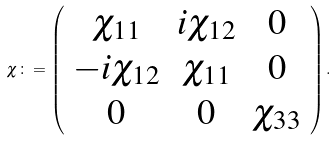<formula> <loc_0><loc_0><loc_500><loc_500>\chi \colon = \left ( \begin{array} { c c c } \chi _ { 1 1 } & i \chi _ { 1 2 } & 0 \\ - i \chi _ { 1 2 } & \chi _ { 1 1 } & 0 \\ 0 & 0 & \chi _ { 3 3 } \end{array} \right ) .</formula> 